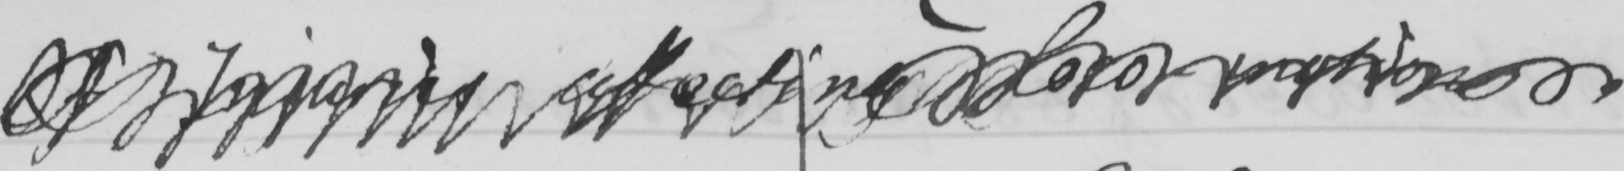What does this handwritten line say? Of Injuries affecting loco-motion 